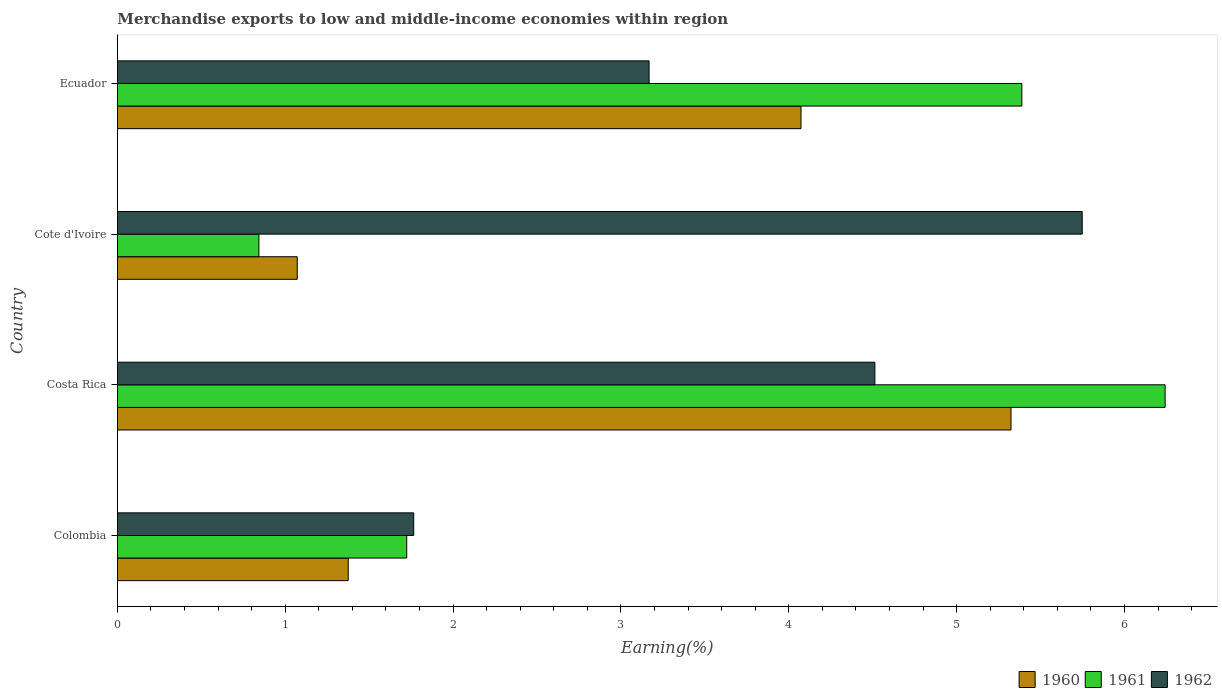How many bars are there on the 2nd tick from the bottom?
Provide a succinct answer. 3. What is the label of the 1st group of bars from the top?
Make the answer very short. Ecuador. In how many cases, is the number of bars for a given country not equal to the number of legend labels?
Offer a terse response. 0. What is the percentage of amount earned from merchandise exports in 1962 in Colombia?
Provide a short and direct response. 1.77. Across all countries, what is the maximum percentage of amount earned from merchandise exports in 1960?
Provide a short and direct response. 5.32. Across all countries, what is the minimum percentage of amount earned from merchandise exports in 1960?
Provide a short and direct response. 1.07. In which country was the percentage of amount earned from merchandise exports in 1961 minimum?
Your answer should be very brief. Cote d'Ivoire. What is the total percentage of amount earned from merchandise exports in 1962 in the graph?
Your answer should be very brief. 15.19. What is the difference between the percentage of amount earned from merchandise exports in 1961 in Costa Rica and that in Cote d'Ivoire?
Your response must be concise. 5.4. What is the difference between the percentage of amount earned from merchandise exports in 1961 in Ecuador and the percentage of amount earned from merchandise exports in 1962 in Colombia?
Ensure brevity in your answer.  3.62. What is the average percentage of amount earned from merchandise exports in 1960 per country?
Offer a very short reply. 2.96. What is the difference between the percentage of amount earned from merchandise exports in 1962 and percentage of amount earned from merchandise exports in 1960 in Cote d'Ivoire?
Provide a succinct answer. 4.68. What is the ratio of the percentage of amount earned from merchandise exports in 1960 in Colombia to that in Ecuador?
Keep it short and to the point. 0.34. Is the difference between the percentage of amount earned from merchandise exports in 1962 in Cote d'Ivoire and Ecuador greater than the difference between the percentage of amount earned from merchandise exports in 1960 in Cote d'Ivoire and Ecuador?
Your response must be concise. Yes. What is the difference between the highest and the second highest percentage of amount earned from merchandise exports in 1962?
Make the answer very short. 1.24. What is the difference between the highest and the lowest percentage of amount earned from merchandise exports in 1961?
Offer a very short reply. 5.4. In how many countries, is the percentage of amount earned from merchandise exports in 1962 greater than the average percentage of amount earned from merchandise exports in 1962 taken over all countries?
Offer a very short reply. 2. Is the sum of the percentage of amount earned from merchandise exports in 1962 in Colombia and Costa Rica greater than the maximum percentage of amount earned from merchandise exports in 1961 across all countries?
Make the answer very short. Yes. What does the 1st bar from the bottom in Cote d'Ivoire represents?
Keep it short and to the point. 1960. How many bars are there?
Provide a short and direct response. 12. How many countries are there in the graph?
Offer a very short reply. 4. What is the title of the graph?
Your answer should be compact. Merchandise exports to low and middle-income economies within region. What is the label or title of the X-axis?
Ensure brevity in your answer.  Earning(%). What is the label or title of the Y-axis?
Your response must be concise. Country. What is the Earning(%) in 1960 in Colombia?
Your answer should be compact. 1.38. What is the Earning(%) of 1961 in Colombia?
Make the answer very short. 1.72. What is the Earning(%) in 1962 in Colombia?
Make the answer very short. 1.77. What is the Earning(%) of 1960 in Costa Rica?
Make the answer very short. 5.32. What is the Earning(%) of 1961 in Costa Rica?
Your answer should be very brief. 6.24. What is the Earning(%) of 1962 in Costa Rica?
Ensure brevity in your answer.  4.51. What is the Earning(%) in 1960 in Cote d'Ivoire?
Your answer should be compact. 1.07. What is the Earning(%) in 1961 in Cote d'Ivoire?
Your response must be concise. 0.84. What is the Earning(%) of 1962 in Cote d'Ivoire?
Give a very brief answer. 5.75. What is the Earning(%) in 1960 in Ecuador?
Make the answer very short. 4.07. What is the Earning(%) of 1961 in Ecuador?
Ensure brevity in your answer.  5.39. What is the Earning(%) in 1962 in Ecuador?
Provide a succinct answer. 3.17. Across all countries, what is the maximum Earning(%) of 1960?
Keep it short and to the point. 5.32. Across all countries, what is the maximum Earning(%) in 1961?
Give a very brief answer. 6.24. Across all countries, what is the maximum Earning(%) in 1962?
Make the answer very short. 5.75. Across all countries, what is the minimum Earning(%) of 1960?
Give a very brief answer. 1.07. Across all countries, what is the minimum Earning(%) in 1961?
Offer a very short reply. 0.84. Across all countries, what is the minimum Earning(%) of 1962?
Your response must be concise. 1.77. What is the total Earning(%) of 1960 in the graph?
Give a very brief answer. 11.84. What is the total Earning(%) in 1961 in the graph?
Offer a very short reply. 14.2. What is the total Earning(%) in 1962 in the graph?
Ensure brevity in your answer.  15.19. What is the difference between the Earning(%) of 1960 in Colombia and that in Costa Rica?
Provide a short and direct response. -3.95. What is the difference between the Earning(%) of 1961 in Colombia and that in Costa Rica?
Ensure brevity in your answer.  -4.52. What is the difference between the Earning(%) in 1962 in Colombia and that in Costa Rica?
Give a very brief answer. -2.75. What is the difference between the Earning(%) of 1960 in Colombia and that in Cote d'Ivoire?
Offer a terse response. 0.3. What is the difference between the Earning(%) in 1961 in Colombia and that in Cote d'Ivoire?
Your response must be concise. 0.88. What is the difference between the Earning(%) in 1962 in Colombia and that in Cote d'Ivoire?
Provide a succinct answer. -3.98. What is the difference between the Earning(%) of 1960 in Colombia and that in Ecuador?
Give a very brief answer. -2.7. What is the difference between the Earning(%) of 1961 in Colombia and that in Ecuador?
Provide a succinct answer. -3.66. What is the difference between the Earning(%) of 1962 in Colombia and that in Ecuador?
Provide a short and direct response. -1.4. What is the difference between the Earning(%) of 1960 in Costa Rica and that in Cote d'Ivoire?
Make the answer very short. 4.25. What is the difference between the Earning(%) in 1961 in Costa Rica and that in Cote d'Ivoire?
Your response must be concise. 5.4. What is the difference between the Earning(%) in 1962 in Costa Rica and that in Cote d'Ivoire?
Your answer should be compact. -1.24. What is the difference between the Earning(%) of 1960 in Costa Rica and that in Ecuador?
Give a very brief answer. 1.25. What is the difference between the Earning(%) of 1961 in Costa Rica and that in Ecuador?
Keep it short and to the point. 0.85. What is the difference between the Earning(%) of 1962 in Costa Rica and that in Ecuador?
Make the answer very short. 1.35. What is the difference between the Earning(%) in 1960 in Cote d'Ivoire and that in Ecuador?
Offer a very short reply. -3. What is the difference between the Earning(%) of 1961 in Cote d'Ivoire and that in Ecuador?
Your answer should be very brief. -4.55. What is the difference between the Earning(%) of 1962 in Cote d'Ivoire and that in Ecuador?
Your answer should be very brief. 2.58. What is the difference between the Earning(%) in 1960 in Colombia and the Earning(%) in 1961 in Costa Rica?
Make the answer very short. -4.87. What is the difference between the Earning(%) in 1960 in Colombia and the Earning(%) in 1962 in Costa Rica?
Make the answer very short. -3.14. What is the difference between the Earning(%) in 1961 in Colombia and the Earning(%) in 1962 in Costa Rica?
Offer a terse response. -2.79. What is the difference between the Earning(%) of 1960 in Colombia and the Earning(%) of 1961 in Cote d'Ivoire?
Ensure brevity in your answer.  0.53. What is the difference between the Earning(%) in 1960 in Colombia and the Earning(%) in 1962 in Cote d'Ivoire?
Make the answer very short. -4.37. What is the difference between the Earning(%) of 1961 in Colombia and the Earning(%) of 1962 in Cote d'Ivoire?
Keep it short and to the point. -4.02. What is the difference between the Earning(%) of 1960 in Colombia and the Earning(%) of 1961 in Ecuador?
Offer a very short reply. -4.01. What is the difference between the Earning(%) in 1960 in Colombia and the Earning(%) in 1962 in Ecuador?
Offer a terse response. -1.79. What is the difference between the Earning(%) of 1961 in Colombia and the Earning(%) of 1962 in Ecuador?
Provide a short and direct response. -1.44. What is the difference between the Earning(%) of 1960 in Costa Rica and the Earning(%) of 1961 in Cote d'Ivoire?
Your answer should be compact. 4.48. What is the difference between the Earning(%) in 1960 in Costa Rica and the Earning(%) in 1962 in Cote d'Ivoire?
Offer a very short reply. -0.42. What is the difference between the Earning(%) of 1961 in Costa Rica and the Earning(%) of 1962 in Cote d'Ivoire?
Give a very brief answer. 0.49. What is the difference between the Earning(%) of 1960 in Costa Rica and the Earning(%) of 1961 in Ecuador?
Provide a short and direct response. -0.06. What is the difference between the Earning(%) in 1960 in Costa Rica and the Earning(%) in 1962 in Ecuador?
Provide a short and direct response. 2.16. What is the difference between the Earning(%) of 1961 in Costa Rica and the Earning(%) of 1962 in Ecuador?
Provide a short and direct response. 3.07. What is the difference between the Earning(%) of 1960 in Cote d'Ivoire and the Earning(%) of 1961 in Ecuador?
Provide a succinct answer. -4.32. What is the difference between the Earning(%) of 1960 in Cote d'Ivoire and the Earning(%) of 1962 in Ecuador?
Offer a very short reply. -2.1. What is the difference between the Earning(%) in 1961 in Cote d'Ivoire and the Earning(%) in 1962 in Ecuador?
Your response must be concise. -2.32. What is the average Earning(%) of 1960 per country?
Make the answer very short. 2.96. What is the average Earning(%) in 1961 per country?
Offer a terse response. 3.55. What is the average Earning(%) of 1962 per country?
Provide a short and direct response. 3.8. What is the difference between the Earning(%) in 1960 and Earning(%) in 1961 in Colombia?
Your answer should be very brief. -0.35. What is the difference between the Earning(%) of 1960 and Earning(%) of 1962 in Colombia?
Make the answer very short. -0.39. What is the difference between the Earning(%) in 1961 and Earning(%) in 1962 in Colombia?
Provide a short and direct response. -0.04. What is the difference between the Earning(%) in 1960 and Earning(%) in 1961 in Costa Rica?
Provide a short and direct response. -0.92. What is the difference between the Earning(%) of 1960 and Earning(%) of 1962 in Costa Rica?
Provide a succinct answer. 0.81. What is the difference between the Earning(%) of 1961 and Earning(%) of 1962 in Costa Rica?
Provide a succinct answer. 1.73. What is the difference between the Earning(%) in 1960 and Earning(%) in 1961 in Cote d'Ivoire?
Provide a short and direct response. 0.23. What is the difference between the Earning(%) in 1960 and Earning(%) in 1962 in Cote d'Ivoire?
Keep it short and to the point. -4.68. What is the difference between the Earning(%) of 1961 and Earning(%) of 1962 in Cote d'Ivoire?
Your answer should be compact. -4.91. What is the difference between the Earning(%) of 1960 and Earning(%) of 1961 in Ecuador?
Provide a succinct answer. -1.32. What is the difference between the Earning(%) in 1960 and Earning(%) in 1962 in Ecuador?
Give a very brief answer. 0.91. What is the difference between the Earning(%) of 1961 and Earning(%) of 1962 in Ecuador?
Provide a succinct answer. 2.22. What is the ratio of the Earning(%) of 1960 in Colombia to that in Costa Rica?
Ensure brevity in your answer.  0.26. What is the ratio of the Earning(%) in 1961 in Colombia to that in Costa Rica?
Offer a terse response. 0.28. What is the ratio of the Earning(%) in 1962 in Colombia to that in Costa Rica?
Your response must be concise. 0.39. What is the ratio of the Earning(%) of 1960 in Colombia to that in Cote d'Ivoire?
Give a very brief answer. 1.28. What is the ratio of the Earning(%) in 1961 in Colombia to that in Cote d'Ivoire?
Give a very brief answer. 2.04. What is the ratio of the Earning(%) in 1962 in Colombia to that in Cote d'Ivoire?
Your answer should be very brief. 0.31. What is the ratio of the Earning(%) of 1960 in Colombia to that in Ecuador?
Provide a succinct answer. 0.34. What is the ratio of the Earning(%) of 1961 in Colombia to that in Ecuador?
Make the answer very short. 0.32. What is the ratio of the Earning(%) of 1962 in Colombia to that in Ecuador?
Provide a short and direct response. 0.56. What is the ratio of the Earning(%) of 1960 in Costa Rica to that in Cote d'Ivoire?
Provide a succinct answer. 4.97. What is the ratio of the Earning(%) in 1961 in Costa Rica to that in Cote d'Ivoire?
Your answer should be very brief. 7.4. What is the ratio of the Earning(%) of 1962 in Costa Rica to that in Cote d'Ivoire?
Provide a succinct answer. 0.79. What is the ratio of the Earning(%) in 1960 in Costa Rica to that in Ecuador?
Your response must be concise. 1.31. What is the ratio of the Earning(%) of 1961 in Costa Rica to that in Ecuador?
Your response must be concise. 1.16. What is the ratio of the Earning(%) in 1962 in Costa Rica to that in Ecuador?
Ensure brevity in your answer.  1.42. What is the ratio of the Earning(%) of 1960 in Cote d'Ivoire to that in Ecuador?
Offer a terse response. 0.26. What is the ratio of the Earning(%) of 1961 in Cote d'Ivoire to that in Ecuador?
Ensure brevity in your answer.  0.16. What is the ratio of the Earning(%) in 1962 in Cote d'Ivoire to that in Ecuador?
Keep it short and to the point. 1.81. What is the difference between the highest and the second highest Earning(%) of 1960?
Provide a short and direct response. 1.25. What is the difference between the highest and the second highest Earning(%) of 1961?
Ensure brevity in your answer.  0.85. What is the difference between the highest and the second highest Earning(%) in 1962?
Provide a succinct answer. 1.24. What is the difference between the highest and the lowest Earning(%) in 1960?
Your answer should be very brief. 4.25. What is the difference between the highest and the lowest Earning(%) of 1961?
Ensure brevity in your answer.  5.4. What is the difference between the highest and the lowest Earning(%) of 1962?
Provide a succinct answer. 3.98. 